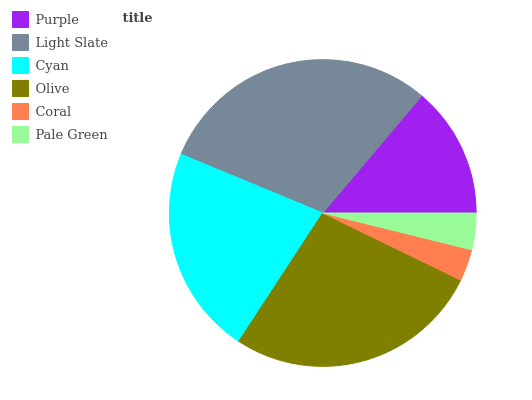Is Coral the minimum?
Answer yes or no. Yes. Is Light Slate the maximum?
Answer yes or no. Yes. Is Cyan the minimum?
Answer yes or no. No. Is Cyan the maximum?
Answer yes or no. No. Is Light Slate greater than Cyan?
Answer yes or no. Yes. Is Cyan less than Light Slate?
Answer yes or no. Yes. Is Cyan greater than Light Slate?
Answer yes or no. No. Is Light Slate less than Cyan?
Answer yes or no. No. Is Cyan the high median?
Answer yes or no. Yes. Is Purple the low median?
Answer yes or no. Yes. Is Pale Green the high median?
Answer yes or no. No. Is Coral the low median?
Answer yes or no. No. 